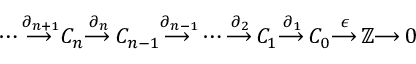<formula> <loc_0><loc_0><loc_500><loc_500>\dots b { \overset { \partial _ { n + 1 } } { \longrightarrow \, } } C _ { n } { \overset { \partial _ { n } } { \longrightarrow \, } } C _ { n - 1 } { \overset { \partial _ { n - 1 } } { \longrightarrow \, } } \dots b { \overset { \partial _ { 2 } } { \longrightarrow \, } } C _ { 1 } { \overset { \partial _ { 1 } } { \longrightarrow \, } } C _ { 0 } { \overset { \epsilon } { \longrightarrow \, } } \mathbb { Z } { \longrightarrow \, } 0</formula> 